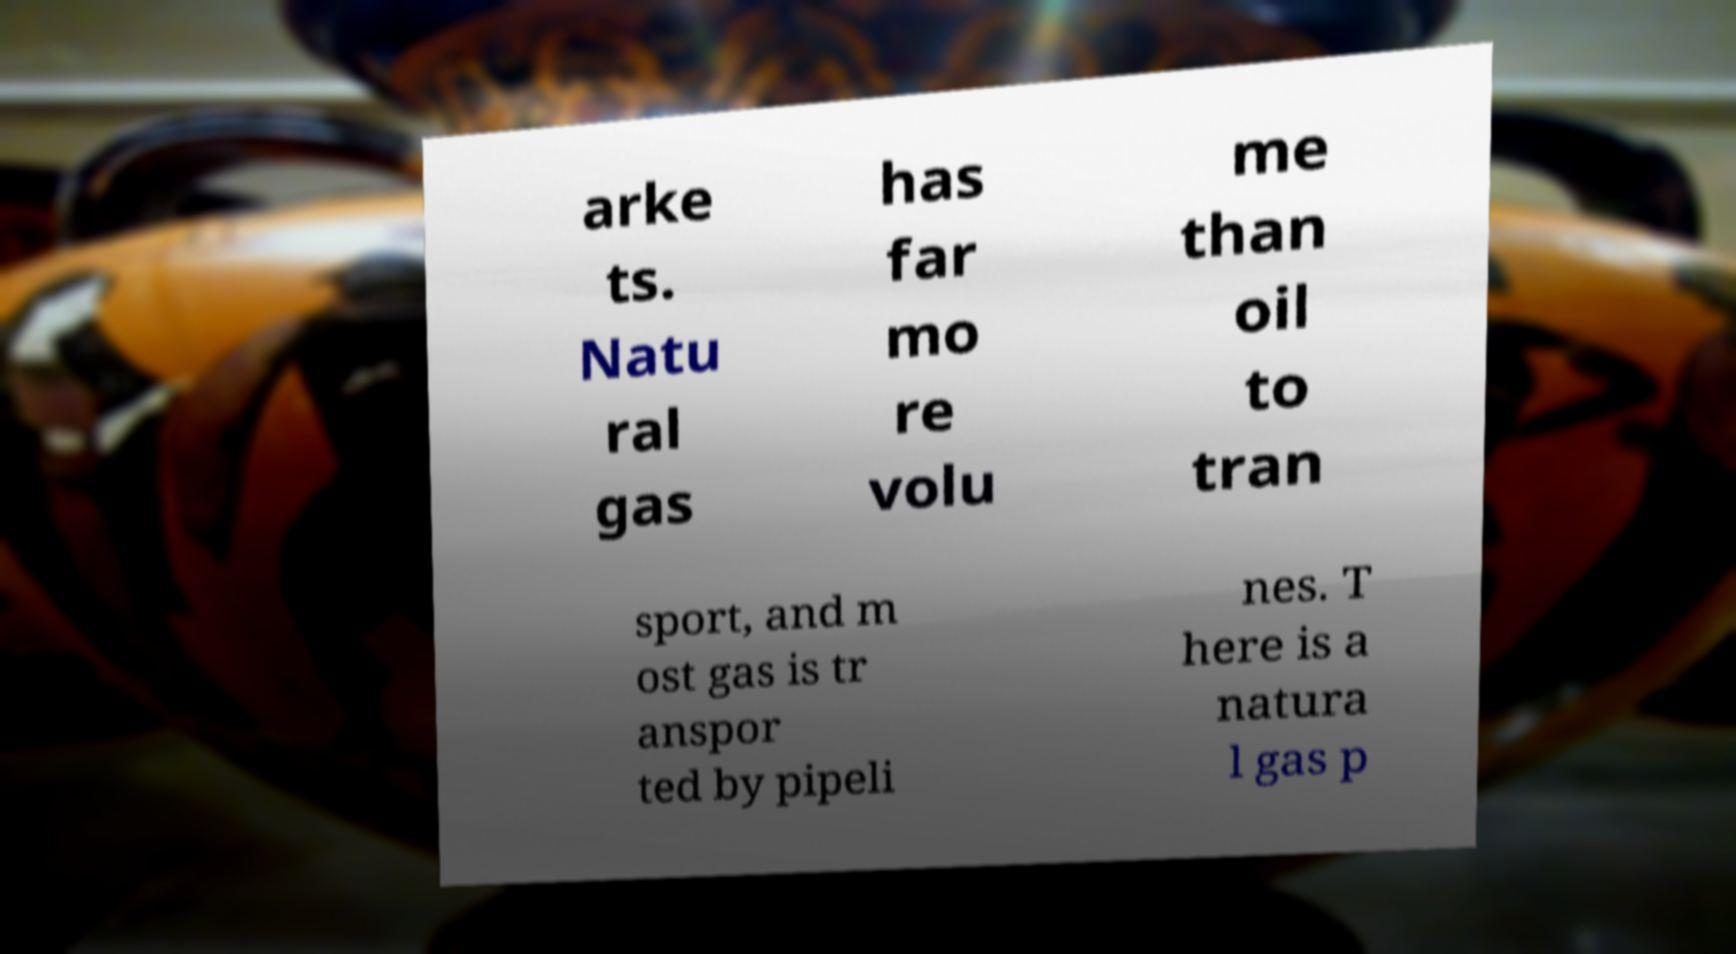For documentation purposes, I need the text within this image transcribed. Could you provide that? arke ts. Natu ral gas has far mo re volu me than oil to tran sport, and m ost gas is tr anspor ted by pipeli nes. T here is a natura l gas p 